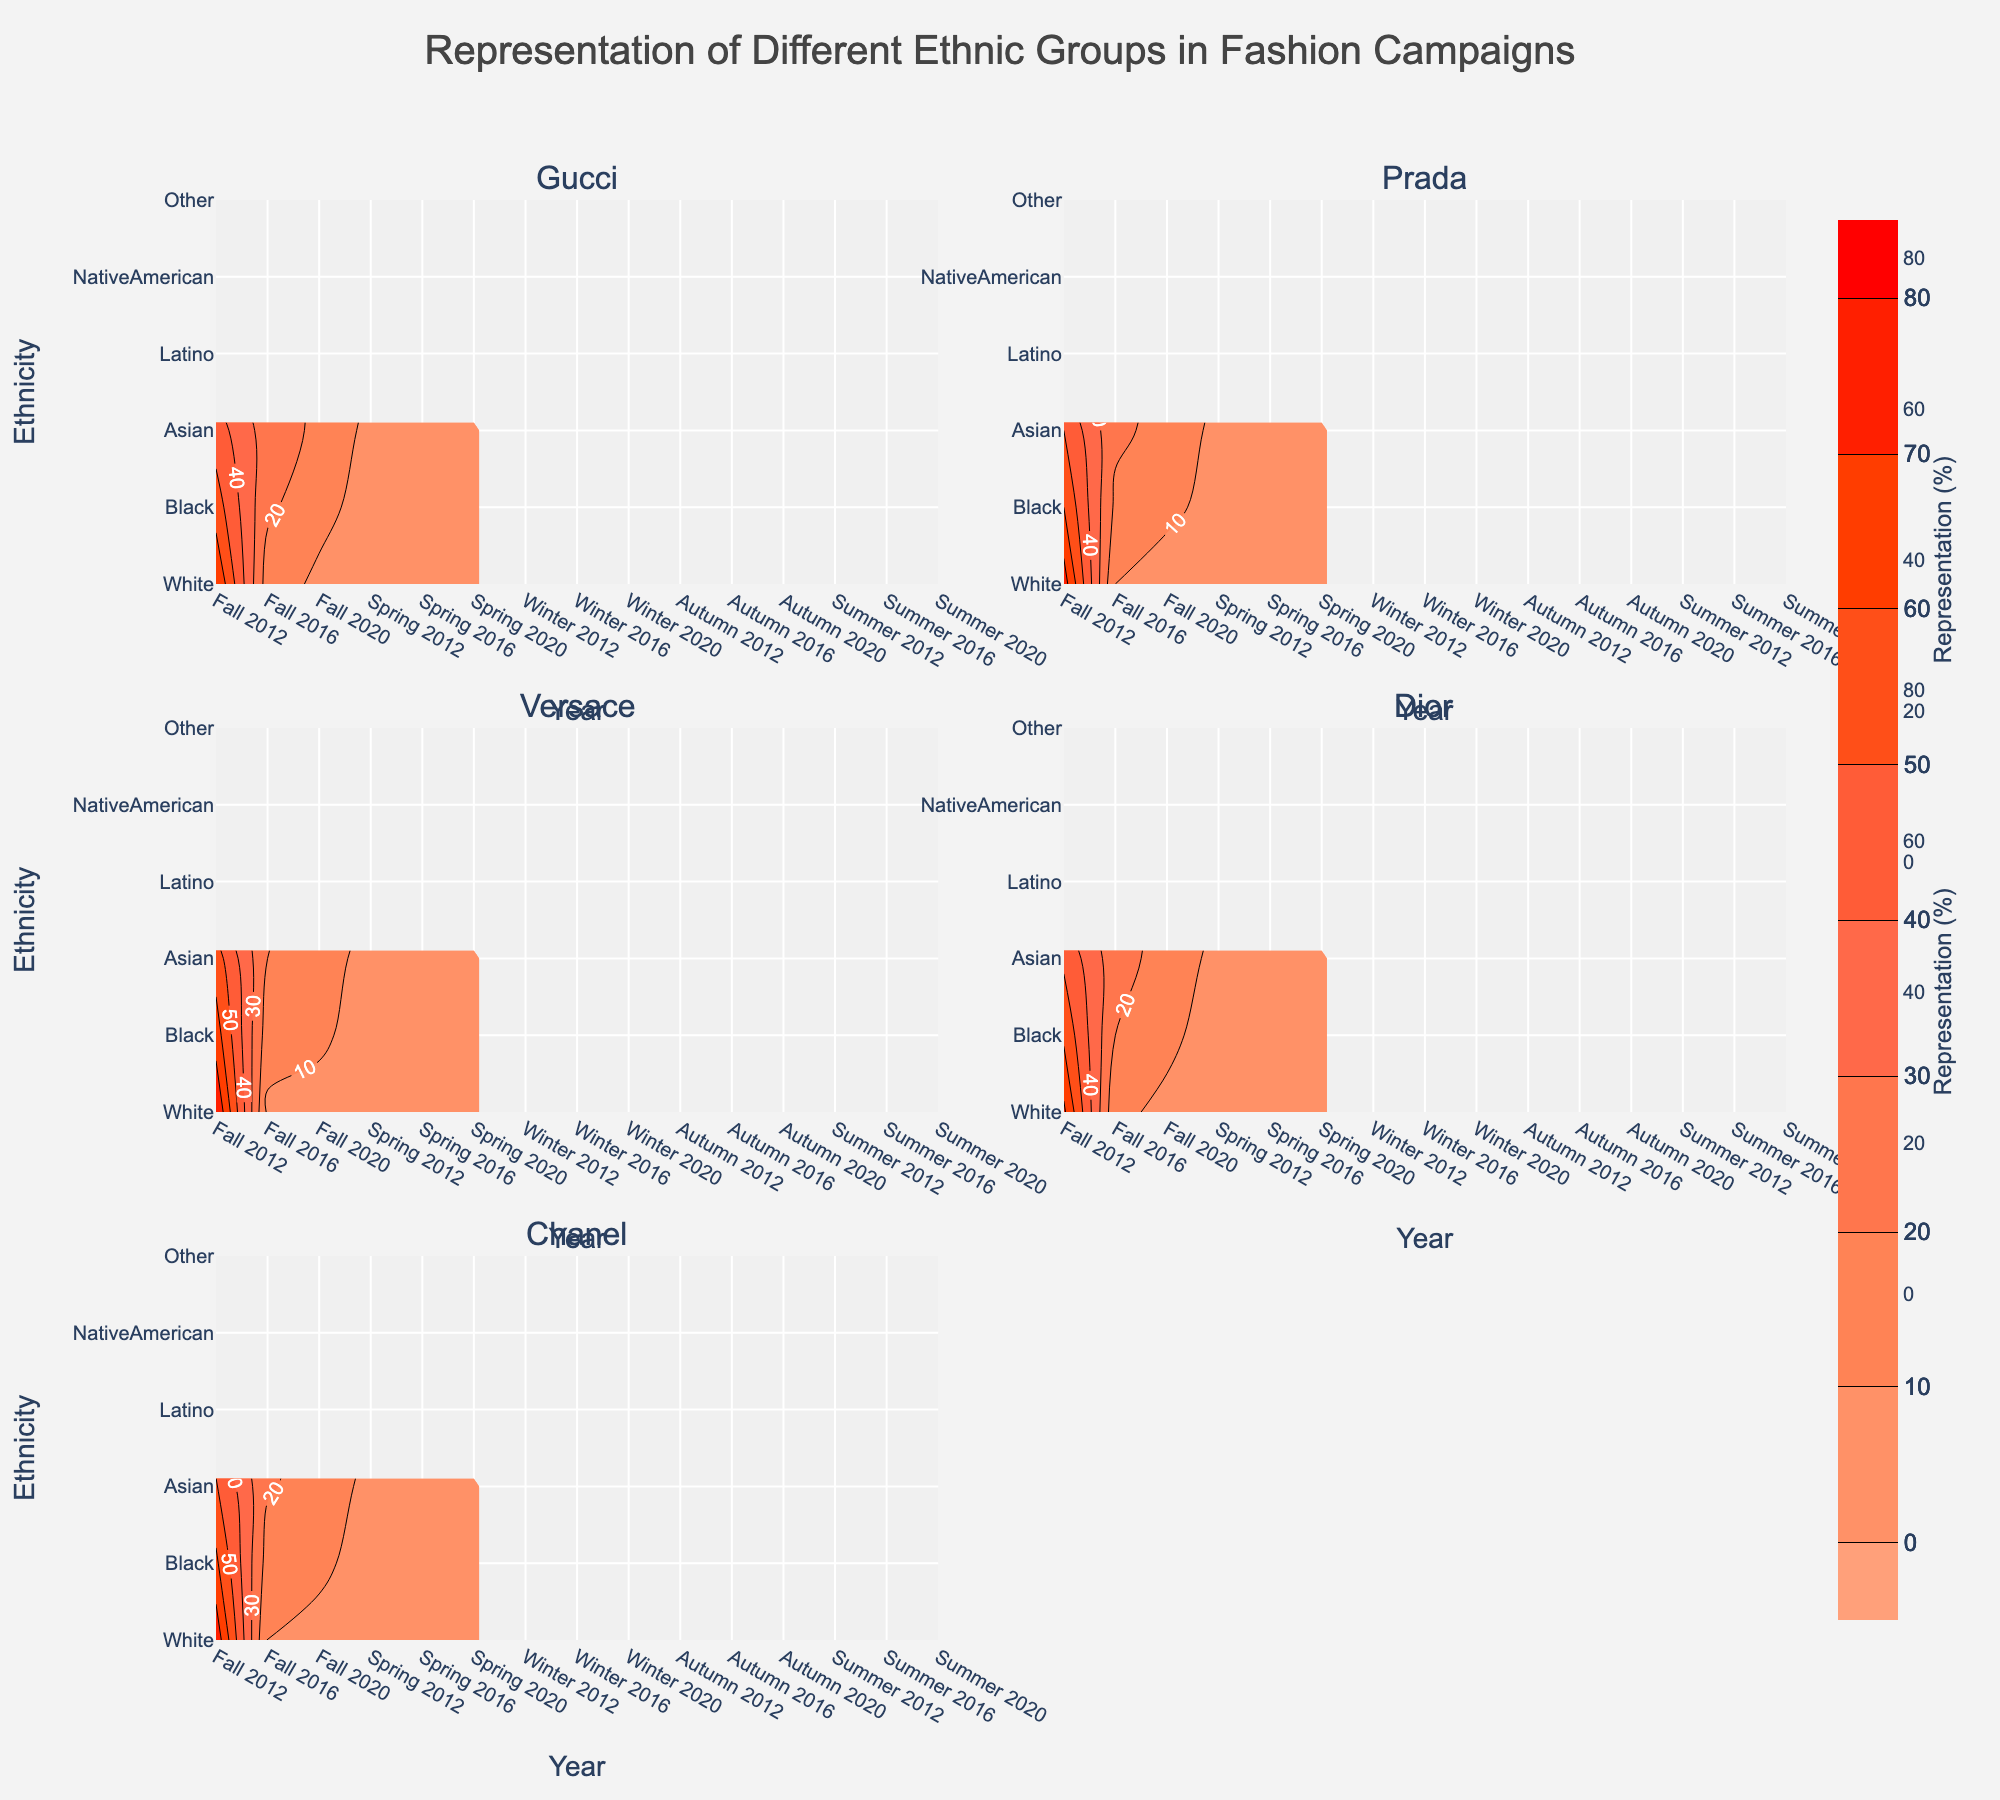How many ethnic groups are represented in each subplot? The y-axis shows the different ethnic groups represented in each campaign. By counting the unique labels on the y-axis, we can determine the number of ethnic groups.
Answer: 6 Which ethnic group had the highest representation in Gucci's Fall 2020 campaign? By analyzing the contour plot for Gucci's Fall 2020 campaign, we look for the highest contour line or label. The group with the highest percentage value is the answer.
Answer: White How did the representation of Black models in Prada campaigns change from Spring 2012 to Spring 2020? Examine the contour plot for Prada campaigns in Spring 2012 and Spring 2020. Compare the representation percentages by finding the corresponding value for Black models.
Answer: Increased Which campaign had the most diverse representation in 2020? Observe the contour subplots for all campaigns in 2020 and compare the presence of different ethnic groups and their representation percentages. The campaign with a relatively equal distribution among the groups is considered the most diverse.
Answer: Dior Are there any ethnic groups consistently underrepresented across all campaigns? By looking at the contour plots for each campaign, identify any ethnic groups with consistently low representation percentages across all campaigns and years. Identify patterns across subplots.
Answer: NativeAmerican, Other 